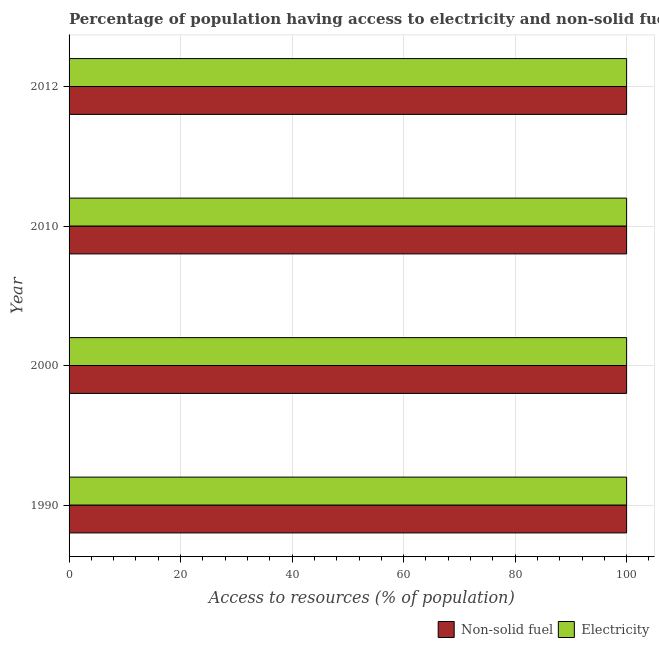Are the number of bars on each tick of the Y-axis equal?
Make the answer very short. Yes. How many bars are there on the 2nd tick from the bottom?
Offer a very short reply. 2. What is the percentage of population having access to electricity in 2012?
Offer a terse response. 100. Across all years, what is the maximum percentage of population having access to non-solid fuel?
Your answer should be compact. 100. Across all years, what is the minimum percentage of population having access to non-solid fuel?
Your response must be concise. 100. In which year was the percentage of population having access to non-solid fuel minimum?
Make the answer very short. 1990. What is the total percentage of population having access to non-solid fuel in the graph?
Keep it short and to the point. 400. What is the difference between the percentage of population having access to non-solid fuel in 1990 and that in 2012?
Your answer should be very brief. 0. What is the difference between the percentage of population having access to non-solid fuel in 2012 and the percentage of population having access to electricity in 2010?
Make the answer very short. 0. Is the difference between the percentage of population having access to non-solid fuel in 2010 and 2012 greater than the difference between the percentage of population having access to electricity in 2010 and 2012?
Keep it short and to the point. No. What is the difference between the highest and the second highest percentage of population having access to electricity?
Ensure brevity in your answer.  0. What is the difference between the highest and the lowest percentage of population having access to electricity?
Offer a terse response. 0. Is the sum of the percentage of population having access to electricity in 2010 and 2012 greater than the maximum percentage of population having access to non-solid fuel across all years?
Offer a terse response. Yes. What does the 2nd bar from the top in 1990 represents?
Offer a terse response. Non-solid fuel. What does the 1st bar from the bottom in 2012 represents?
Offer a terse response. Non-solid fuel. Are all the bars in the graph horizontal?
Provide a short and direct response. Yes. Are the values on the major ticks of X-axis written in scientific E-notation?
Keep it short and to the point. No. Does the graph contain any zero values?
Your answer should be compact. No. Where does the legend appear in the graph?
Your answer should be compact. Bottom right. How many legend labels are there?
Give a very brief answer. 2. How are the legend labels stacked?
Provide a succinct answer. Horizontal. What is the title of the graph?
Ensure brevity in your answer.  Percentage of population having access to electricity and non-solid fuels in Switzerland. Does "Long-term debt" appear as one of the legend labels in the graph?
Keep it short and to the point. No. What is the label or title of the X-axis?
Keep it short and to the point. Access to resources (% of population). What is the Access to resources (% of population) of Electricity in 1990?
Your answer should be very brief. 100. What is the Access to resources (% of population) of Non-solid fuel in 2000?
Ensure brevity in your answer.  100. What is the Access to resources (% of population) in Electricity in 2000?
Your answer should be compact. 100. What is the Access to resources (% of population) in Non-solid fuel in 2010?
Provide a succinct answer. 100. What is the Access to resources (% of population) in Non-solid fuel in 2012?
Offer a very short reply. 100. What is the Access to resources (% of population) of Electricity in 2012?
Your answer should be compact. 100. Across all years, what is the maximum Access to resources (% of population) in Non-solid fuel?
Your answer should be very brief. 100. Across all years, what is the maximum Access to resources (% of population) in Electricity?
Keep it short and to the point. 100. Across all years, what is the minimum Access to resources (% of population) of Electricity?
Provide a succinct answer. 100. What is the total Access to resources (% of population) of Electricity in the graph?
Provide a short and direct response. 400. What is the difference between the Access to resources (% of population) in Electricity in 1990 and that in 2000?
Give a very brief answer. 0. What is the difference between the Access to resources (% of population) in Non-solid fuel in 2000 and that in 2010?
Offer a terse response. 0. What is the difference between the Access to resources (% of population) in Electricity in 2000 and that in 2010?
Make the answer very short. 0. What is the difference between the Access to resources (% of population) of Electricity in 2000 and that in 2012?
Offer a very short reply. 0. What is the difference between the Access to resources (% of population) in Non-solid fuel in 2010 and that in 2012?
Offer a terse response. 0. What is the difference between the Access to resources (% of population) in Electricity in 2010 and that in 2012?
Provide a short and direct response. 0. What is the difference between the Access to resources (% of population) of Non-solid fuel in 1990 and the Access to resources (% of population) of Electricity in 2012?
Your answer should be compact. 0. What is the difference between the Access to resources (% of population) of Non-solid fuel in 2000 and the Access to resources (% of population) of Electricity in 2010?
Provide a succinct answer. 0. In the year 1990, what is the difference between the Access to resources (% of population) in Non-solid fuel and Access to resources (% of population) in Electricity?
Keep it short and to the point. 0. In the year 2010, what is the difference between the Access to resources (% of population) of Non-solid fuel and Access to resources (% of population) of Electricity?
Provide a succinct answer. 0. What is the ratio of the Access to resources (% of population) of Non-solid fuel in 1990 to that in 2000?
Ensure brevity in your answer.  1. What is the ratio of the Access to resources (% of population) in Electricity in 1990 to that in 2000?
Provide a short and direct response. 1. What is the ratio of the Access to resources (% of population) in Non-solid fuel in 1990 to that in 2012?
Offer a terse response. 1. What is the ratio of the Access to resources (% of population) of Non-solid fuel in 2000 to that in 2010?
Ensure brevity in your answer.  1. What is the ratio of the Access to resources (% of population) of Electricity in 2000 to that in 2010?
Offer a terse response. 1. What is the ratio of the Access to resources (% of population) of Non-solid fuel in 2000 to that in 2012?
Provide a short and direct response. 1. What is the ratio of the Access to resources (% of population) of Electricity in 2000 to that in 2012?
Provide a short and direct response. 1. What is the difference between the highest and the second highest Access to resources (% of population) of Electricity?
Offer a terse response. 0. What is the difference between the highest and the lowest Access to resources (% of population) of Non-solid fuel?
Your response must be concise. 0. What is the difference between the highest and the lowest Access to resources (% of population) of Electricity?
Your response must be concise. 0. 